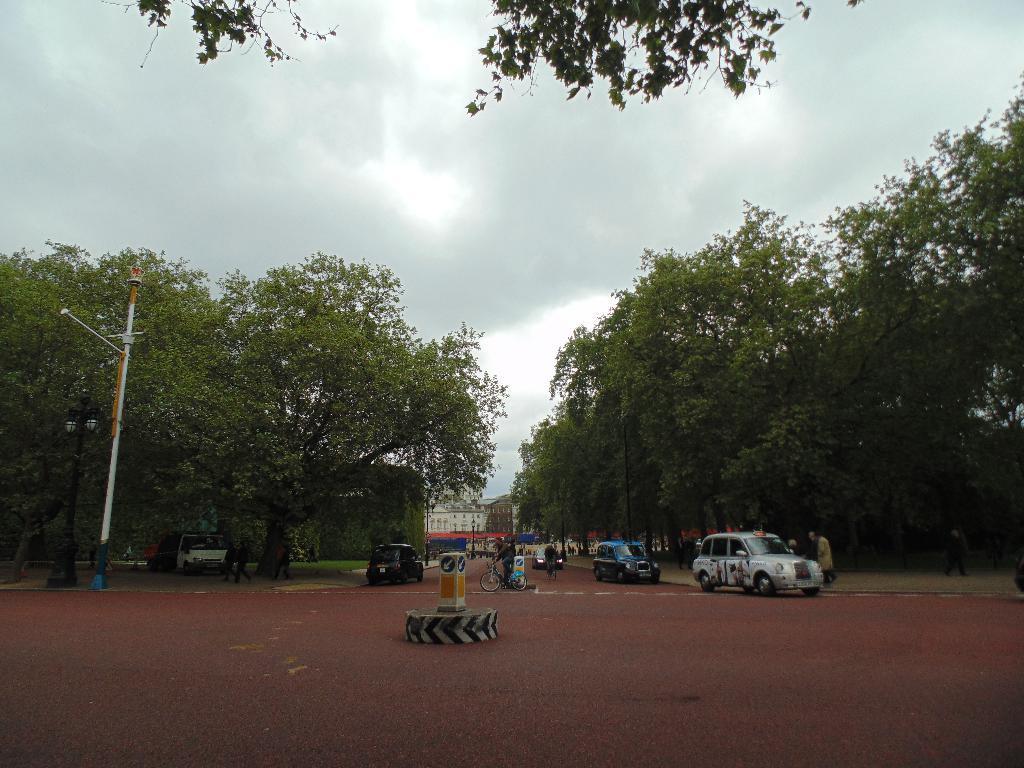Can you describe this image briefly? In this image I can see few vehicles on the road. I can also see a person riding bicycle, background I can see trees in green color, a light pole, an electric pole and the sky is in white color. 